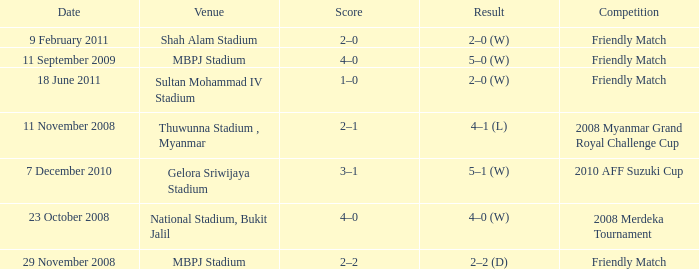What is the Result of the Competition at MBPJ Stadium with a Score of 4–0? 5–0 (W). 